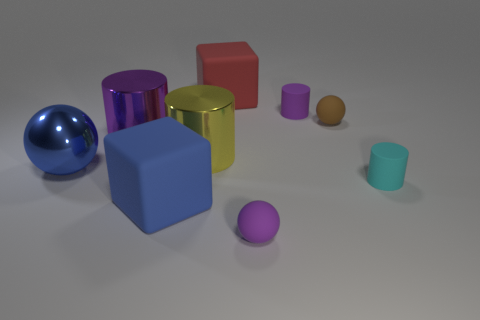Subtract all green balls. How many purple cylinders are left? 2 Subtract all tiny rubber spheres. How many spheres are left? 1 Subtract all yellow cylinders. How many cylinders are left? 3 Subtract 1 spheres. How many spheres are left? 2 Add 1 cyan things. How many objects exist? 10 Subtract all blue cylinders. Subtract all gray cubes. How many cylinders are left? 4 Add 5 brown matte objects. How many brown matte objects are left? 6 Add 2 tiny brown metal cylinders. How many tiny brown metal cylinders exist? 2 Subtract 0 green spheres. How many objects are left? 9 Subtract all cubes. How many objects are left? 7 